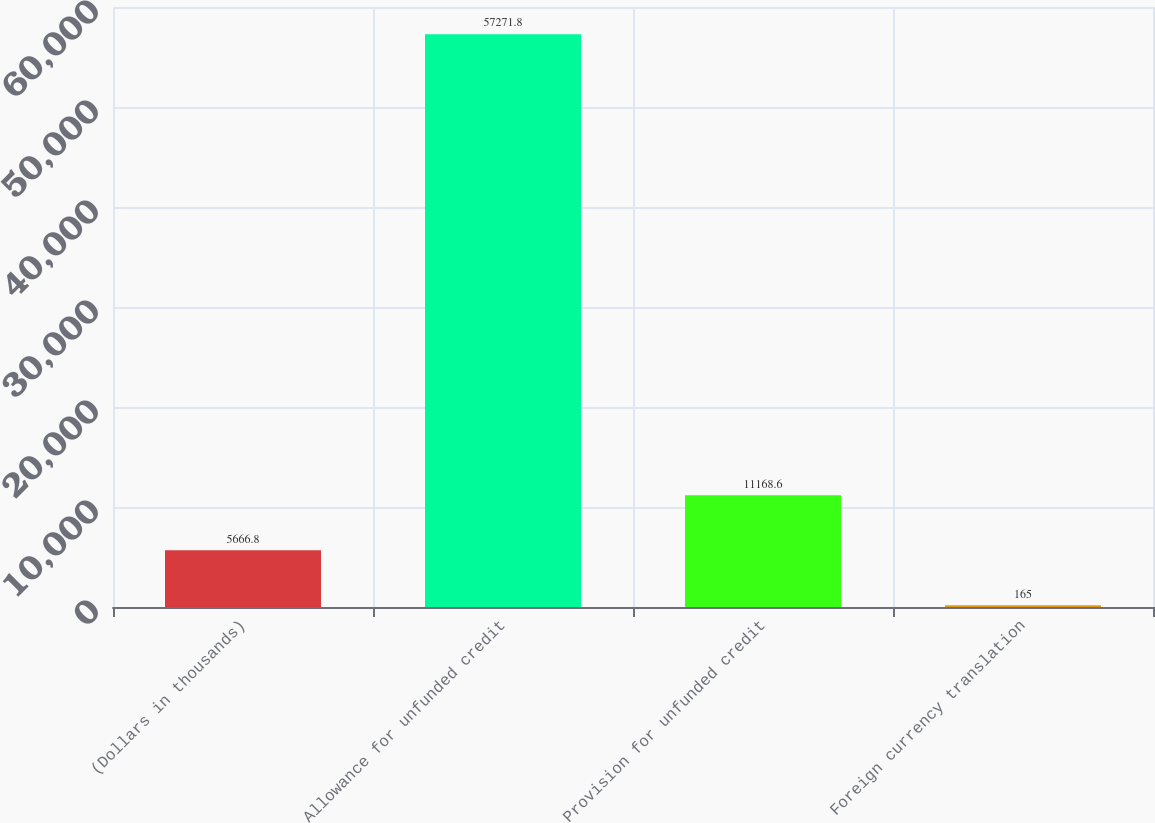<chart> <loc_0><loc_0><loc_500><loc_500><bar_chart><fcel>(Dollars in thousands)<fcel>Allowance for unfunded credit<fcel>Provision for unfunded credit<fcel>Foreign currency translation<nl><fcel>5666.8<fcel>57271.8<fcel>11168.6<fcel>165<nl></chart> 